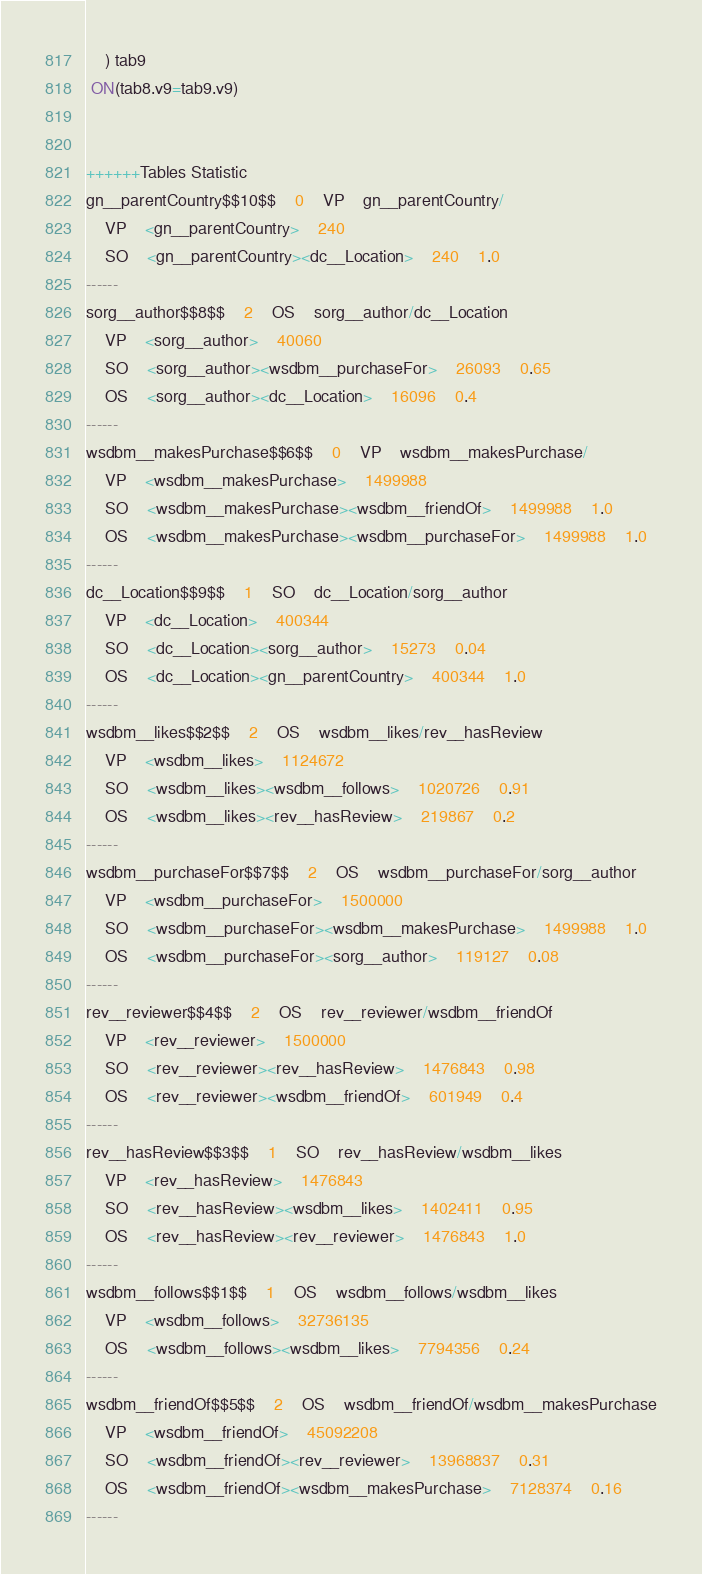Convert code to text. <code><loc_0><loc_0><loc_500><loc_500><_SQL_>	) tab9
 ON(tab8.v9=tab9.v9)


++++++Tables Statistic
gn__parentCountry$$10$$	0	VP	gn__parentCountry/
	VP	<gn__parentCountry>	240
	SO	<gn__parentCountry><dc__Location>	240	1.0
------
sorg__author$$8$$	2	OS	sorg__author/dc__Location
	VP	<sorg__author>	40060
	SO	<sorg__author><wsdbm__purchaseFor>	26093	0.65
	OS	<sorg__author><dc__Location>	16096	0.4
------
wsdbm__makesPurchase$$6$$	0	VP	wsdbm__makesPurchase/
	VP	<wsdbm__makesPurchase>	1499988
	SO	<wsdbm__makesPurchase><wsdbm__friendOf>	1499988	1.0
	OS	<wsdbm__makesPurchase><wsdbm__purchaseFor>	1499988	1.0
------
dc__Location$$9$$	1	SO	dc__Location/sorg__author
	VP	<dc__Location>	400344
	SO	<dc__Location><sorg__author>	15273	0.04
	OS	<dc__Location><gn__parentCountry>	400344	1.0
------
wsdbm__likes$$2$$	2	OS	wsdbm__likes/rev__hasReview
	VP	<wsdbm__likes>	1124672
	SO	<wsdbm__likes><wsdbm__follows>	1020726	0.91
	OS	<wsdbm__likes><rev__hasReview>	219867	0.2
------
wsdbm__purchaseFor$$7$$	2	OS	wsdbm__purchaseFor/sorg__author
	VP	<wsdbm__purchaseFor>	1500000
	SO	<wsdbm__purchaseFor><wsdbm__makesPurchase>	1499988	1.0
	OS	<wsdbm__purchaseFor><sorg__author>	119127	0.08
------
rev__reviewer$$4$$	2	OS	rev__reviewer/wsdbm__friendOf
	VP	<rev__reviewer>	1500000
	SO	<rev__reviewer><rev__hasReview>	1476843	0.98
	OS	<rev__reviewer><wsdbm__friendOf>	601949	0.4
------
rev__hasReview$$3$$	1	SO	rev__hasReview/wsdbm__likes
	VP	<rev__hasReview>	1476843
	SO	<rev__hasReview><wsdbm__likes>	1402411	0.95
	OS	<rev__hasReview><rev__reviewer>	1476843	1.0
------
wsdbm__follows$$1$$	1	OS	wsdbm__follows/wsdbm__likes
	VP	<wsdbm__follows>	32736135
	OS	<wsdbm__follows><wsdbm__likes>	7794356	0.24
------
wsdbm__friendOf$$5$$	2	OS	wsdbm__friendOf/wsdbm__makesPurchase
	VP	<wsdbm__friendOf>	45092208
	SO	<wsdbm__friendOf><rev__reviewer>	13968837	0.31
	OS	<wsdbm__friendOf><wsdbm__makesPurchase>	7128374	0.16
------
</code> 